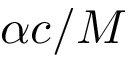<formula> <loc_0><loc_0><loc_500><loc_500>\alpha c / M</formula> 